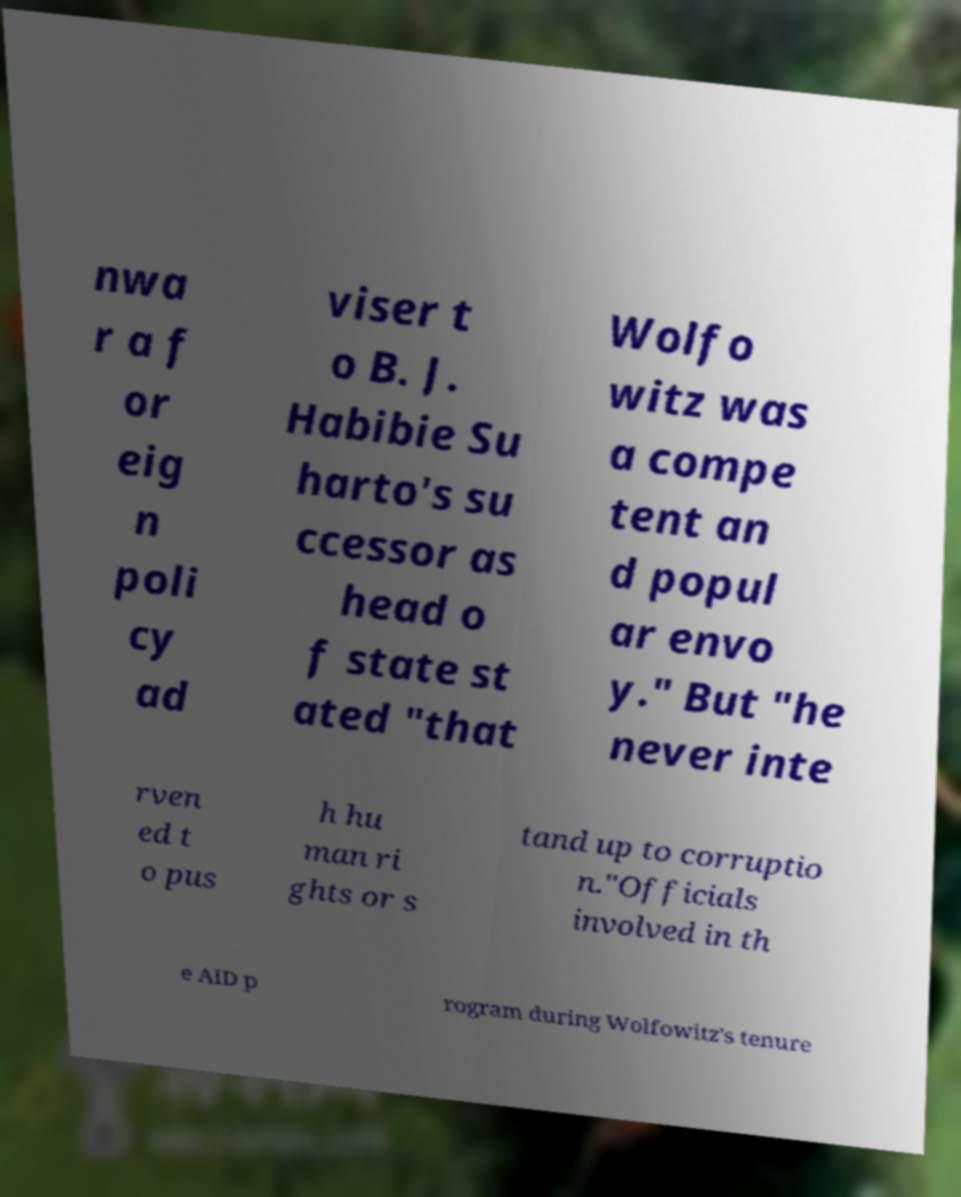Could you extract and type out the text from this image? nwa r a f or eig n poli cy ad viser t o B. J. Habibie Su harto's su ccessor as head o f state st ated "that Wolfo witz was a compe tent an d popul ar envo y." But "he never inte rven ed t o pus h hu man ri ghts or s tand up to corruptio n."Officials involved in th e AID p rogram during Wolfowitz's tenure 